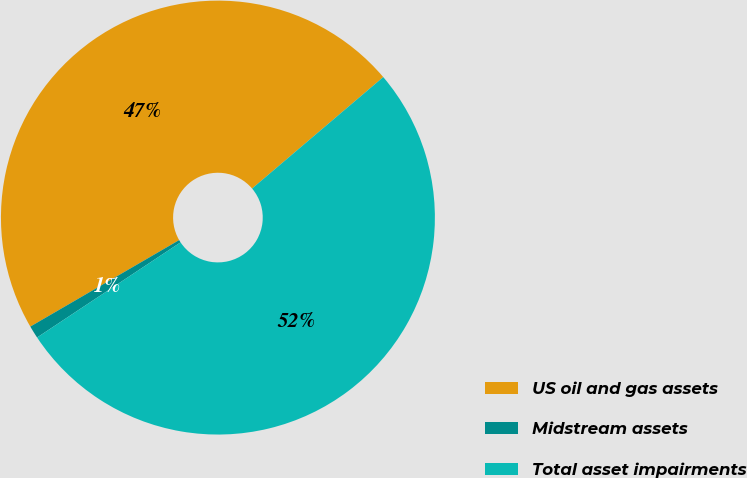<chart> <loc_0><loc_0><loc_500><loc_500><pie_chart><fcel>US oil and gas assets<fcel>Midstream assets<fcel>Total asset impairments<nl><fcel>47.17%<fcel>0.94%<fcel>51.89%<nl></chart> 